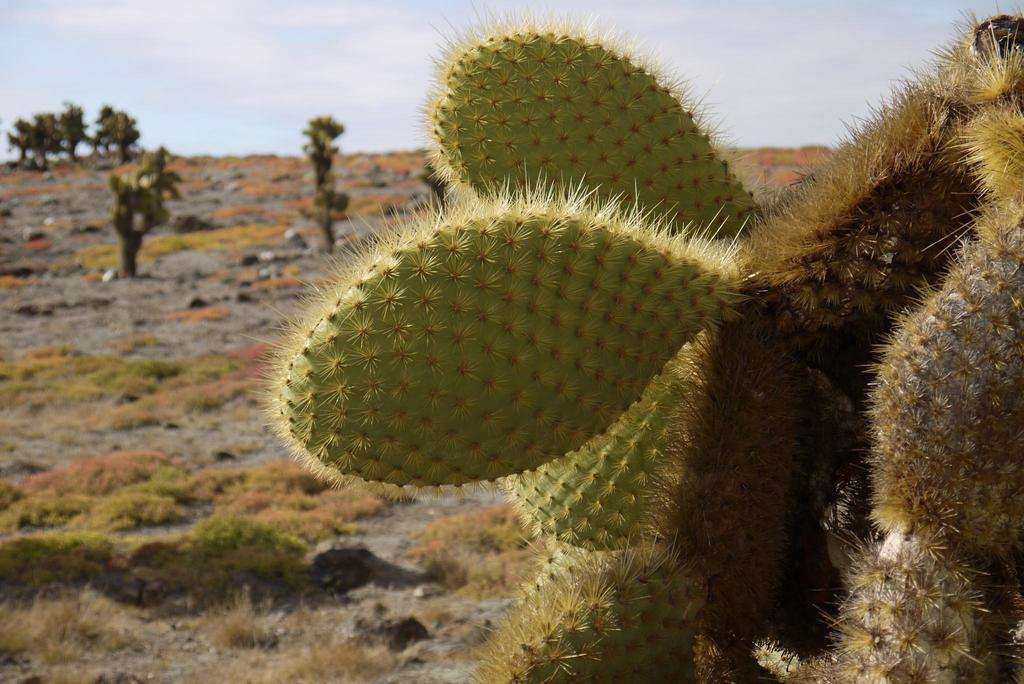What type of plant is in the image? There is a cactus plant in the image. What can be seen behind the cactus plant? There are trees behind the cactus plant. What type of vegetation is visible around the land in the image? There is grass visible around the land in the image. Where is the throne located in the image? There is no throne present in the image. What type of food is being served for lunch in the image? There is no mention of lunch or food in the image. 